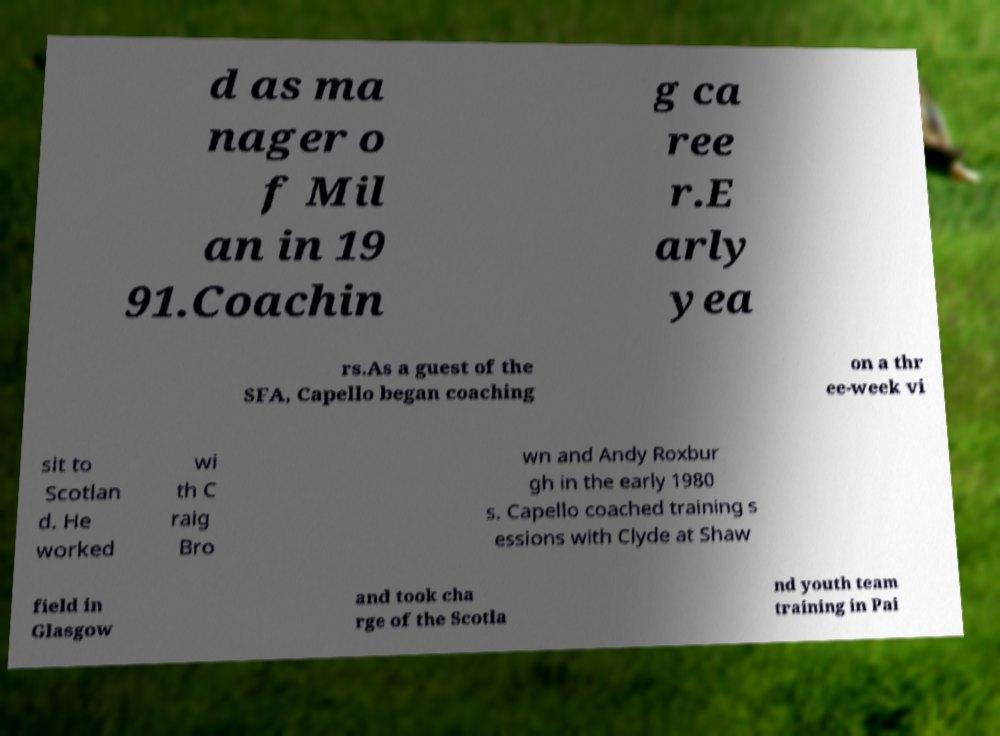Can you read and provide the text displayed in the image?This photo seems to have some interesting text. Can you extract and type it out for me? d as ma nager o f Mil an in 19 91.Coachin g ca ree r.E arly yea rs.As a guest of the SFA, Capello began coaching on a thr ee-week vi sit to Scotlan d. He worked wi th C raig Bro wn and Andy Roxbur gh in the early 1980 s. Capello coached training s essions with Clyde at Shaw field in Glasgow and took cha rge of the Scotla nd youth team training in Pai 